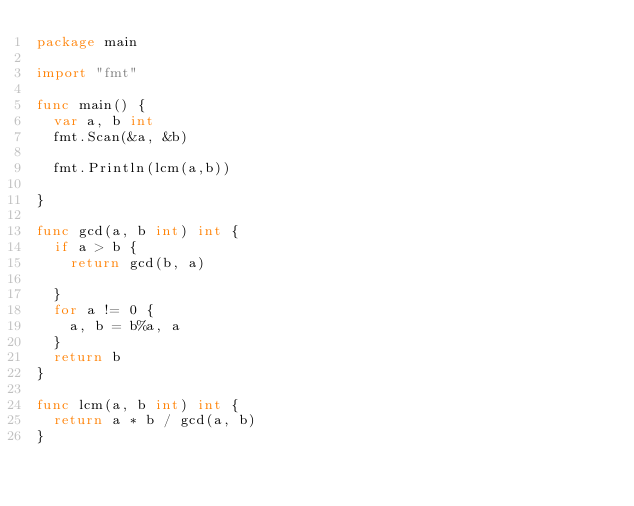<code> <loc_0><loc_0><loc_500><loc_500><_Go_>package main

import "fmt"

func main() {
	var a, b int
	fmt.Scan(&a, &b)

	fmt.Println(lcm(a,b))

}

func gcd(a, b int) int {
	if a > b {
		return gcd(b, a)

	}
	for a != 0 {
		a, b = b%a, a
	}
	return b
}

func lcm(a, b int) int {
	return a * b / gcd(a, b)
}
</code> 